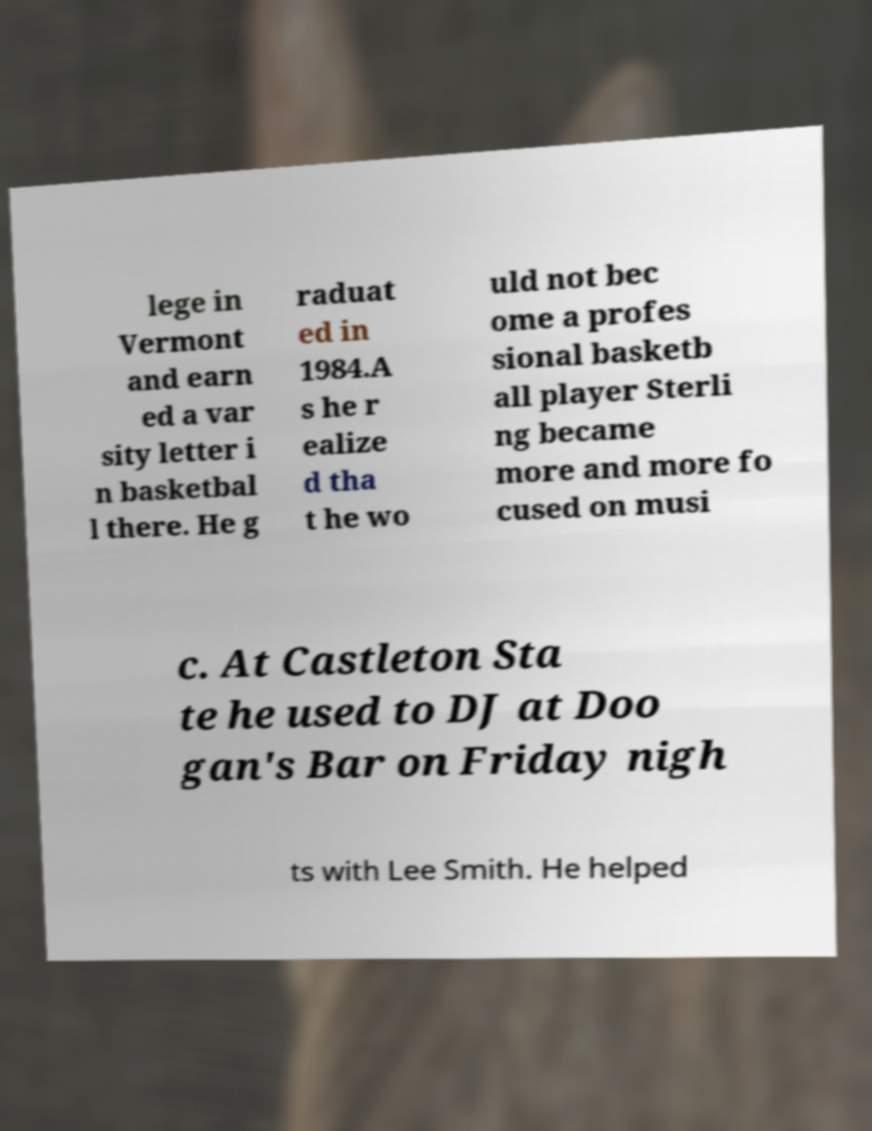Can you accurately transcribe the text from the provided image for me? lege in Vermont and earn ed a var sity letter i n basketbal l there. He g raduat ed in 1984.A s he r ealize d tha t he wo uld not bec ome a profes sional basketb all player Sterli ng became more and more fo cused on musi c. At Castleton Sta te he used to DJ at Doo gan's Bar on Friday nigh ts with Lee Smith. He helped 